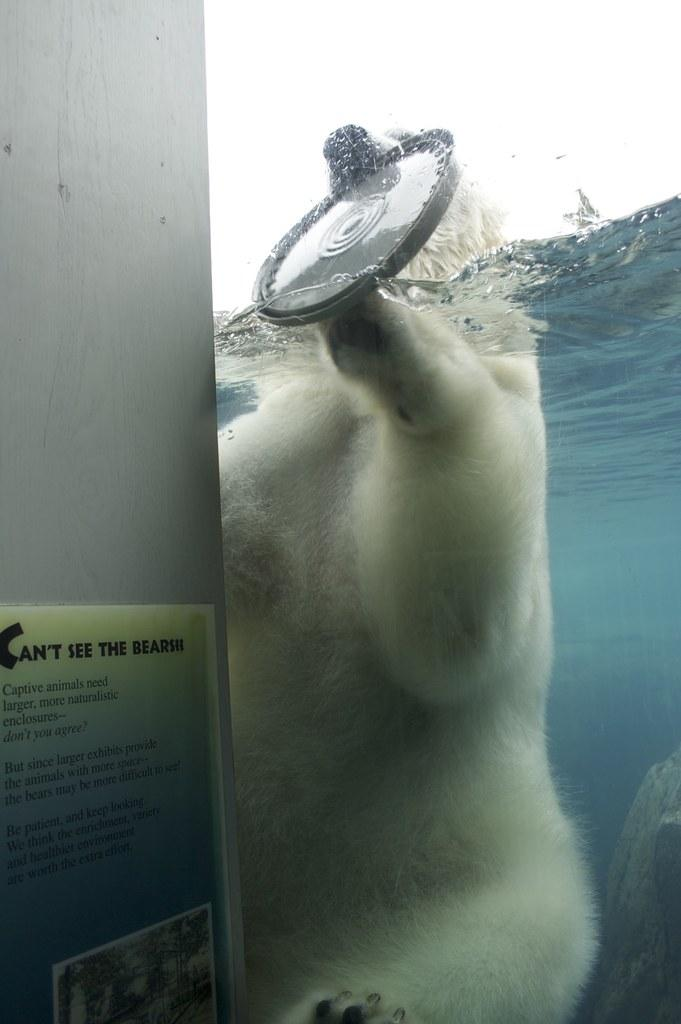What animal is in the water in the center of the image? There is a polar bear in the water in the center of the image. What is the polar bear holding in its jaws? The polar bear is holding a disk-like object in its jaws. What can be seen on the left side of the image? There appears to be a wall on the left side of the image. What is on the wall? There is a poster on the wall. What thought is the polar bear having while holding the disk-like object in the image? There is no way to determine the polar bear's thoughts from the image, as animals do not have the ability to express or communicate their thoughts in the same way humans do. 